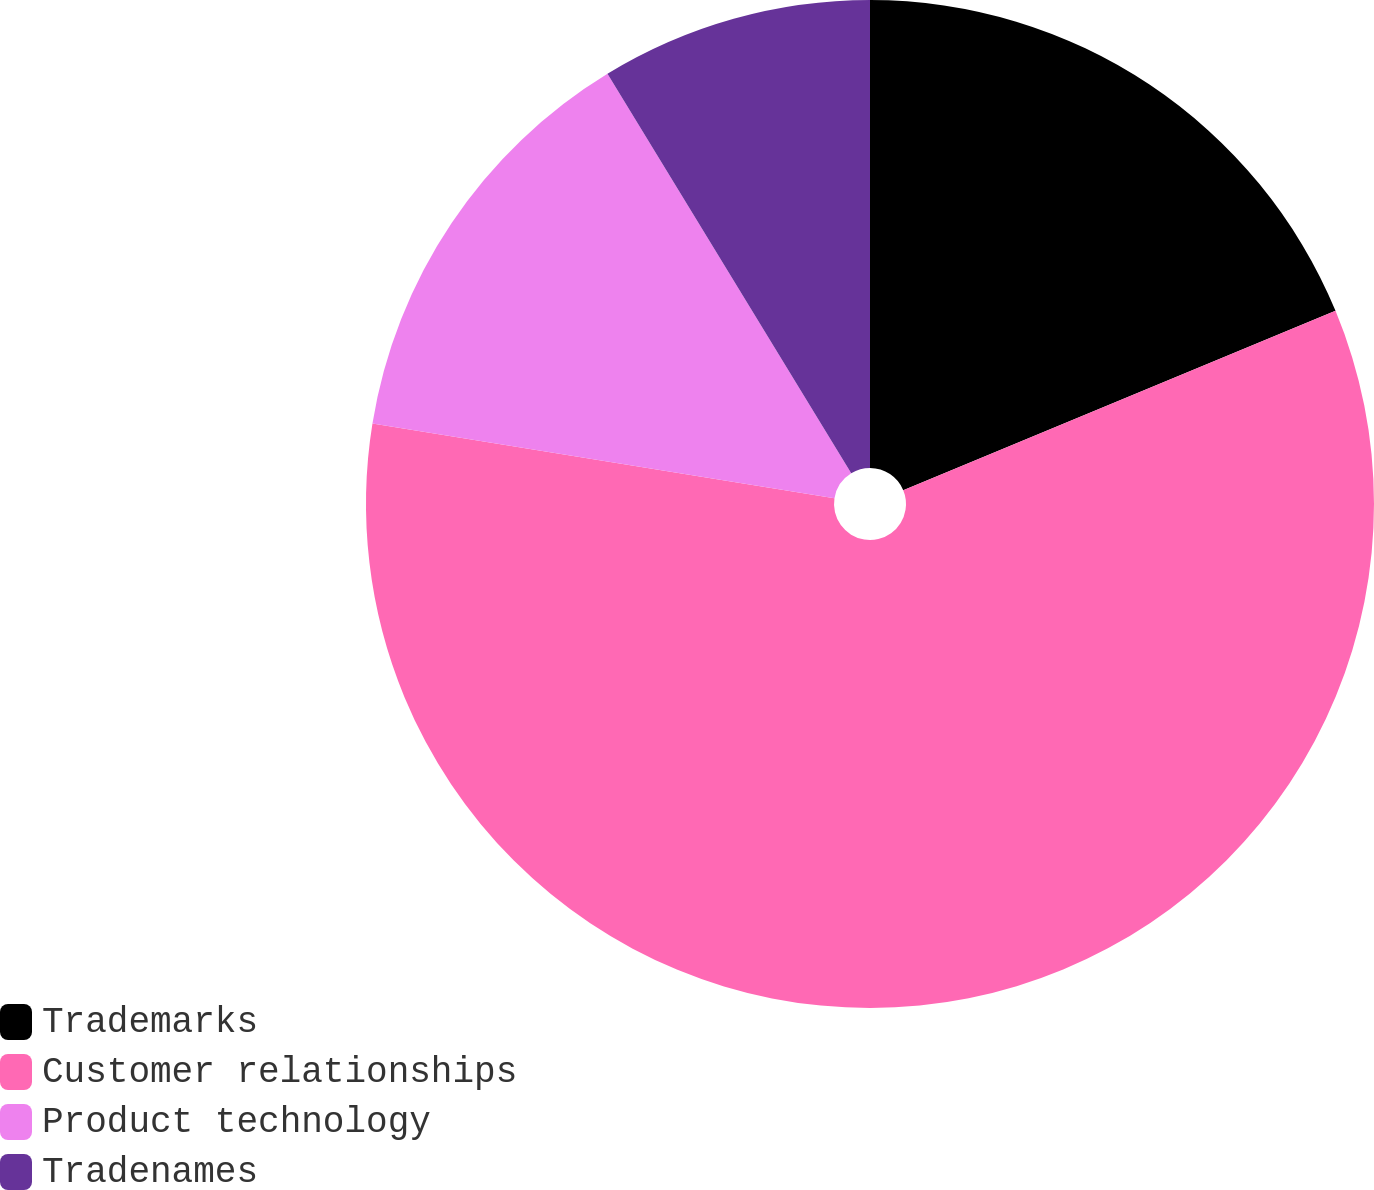<chart> <loc_0><loc_0><loc_500><loc_500><pie_chart><fcel>Trademarks<fcel>Customer relationships<fcel>Product technology<fcel>Tradenames<nl><fcel>18.74%<fcel>58.81%<fcel>13.73%<fcel>8.72%<nl></chart> 